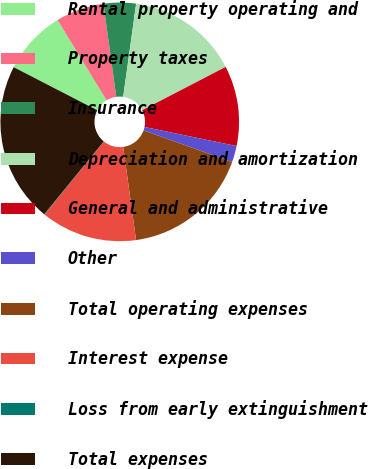Convert chart. <chart><loc_0><loc_0><loc_500><loc_500><pie_chart><fcel>Rental property operating and<fcel>Property taxes<fcel>Insurance<fcel>Depreciation and amortization<fcel>General and administrative<fcel>Other<fcel>Total operating expenses<fcel>Interest expense<fcel>Loss from early extinguishment<fcel>Total expenses<nl><fcel>8.7%<fcel>6.54%<fcel>4.38%<fcel>15.19%<fcel>10.86%<fcel>2.22%<fcel>17.35%<fcel>13.03%<fcel>0.06%<fcel>21.67%<nl></chart> 